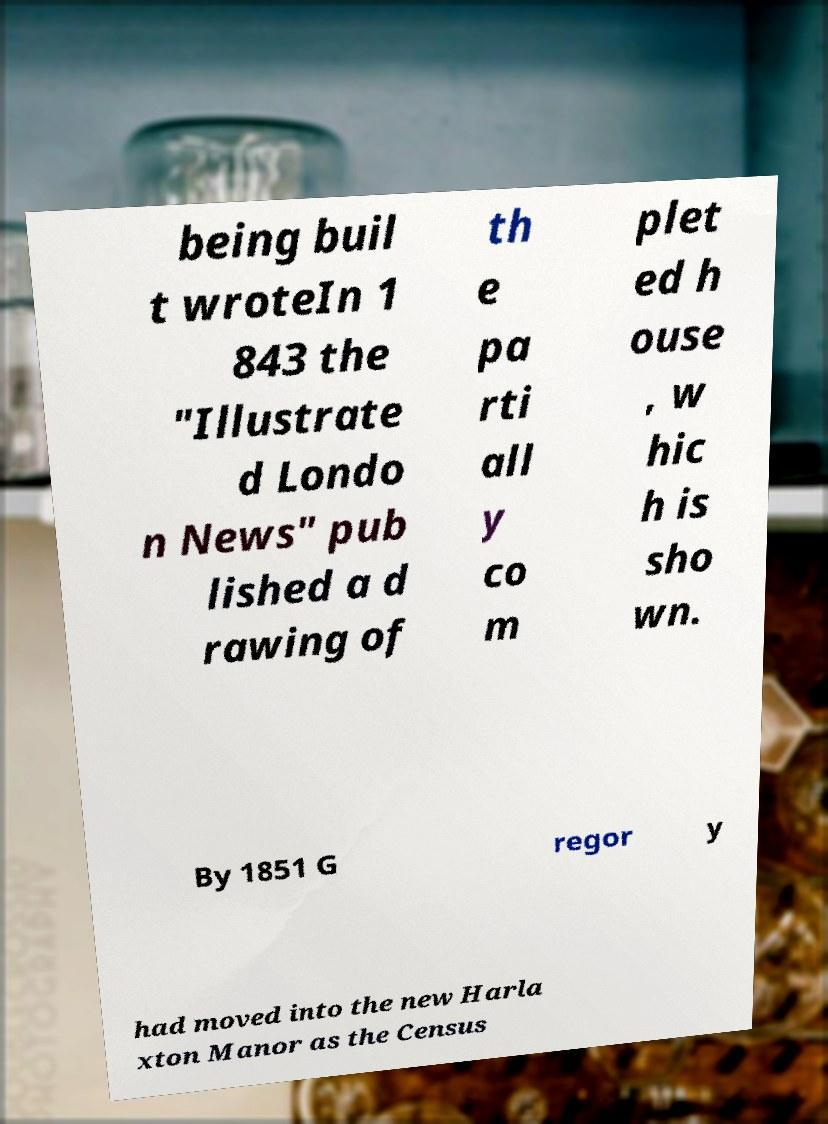What messages or text are displayed in this image? I need them in a readable, typed format. being buil t wroteIn 1 843 the "Illustrate d Londo n News" pub lished a d rawing of th e pa rti all y co m plet ed h ouse , w hic h is sho wn. By 1851 G regor y had moved into the new Harla xton Manor as the Census 